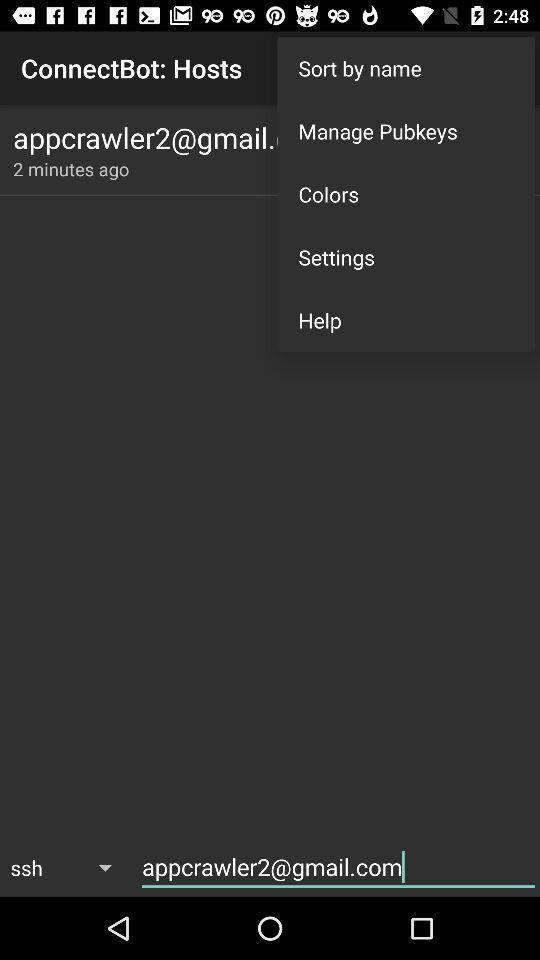How many minutes ago the email address is updated? It was updated 2 minutes ago. 